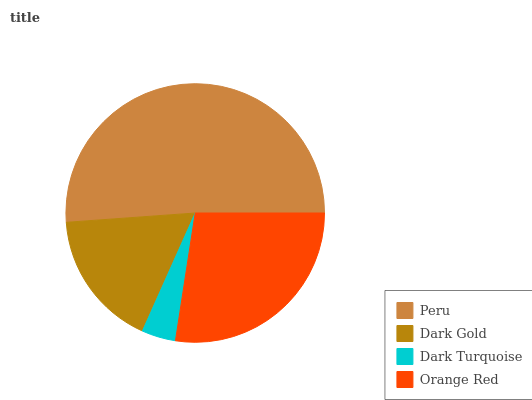Is Dark Turquoise the minimum?
Answer yes or no. Yes. Is Peru the maximum?
Answer yes or no. Yes. Is Dark Gold the minimum?
Answer yes or no. No. Is Dark Gold the maximum?
Answer yes or no. No. Is Peru greater than Dark Gold?
Answer yes or no. Yes. Is Dark Gold less than Peru?
Answer yes or no. Yes. Is Dark Gold greater than Peru?
Answer yes or no. No. Is Peru less than Dark Gold?
Answer yes or no. No. Is Orange Red the high median?
Answer yes or no. Yes. Is Dark Gold the low median?
Answer yes or no. Yes. Is Peru the high median?
Answer yes or no. No. Is Orange Red the low median?
Answer yes or no. No. 